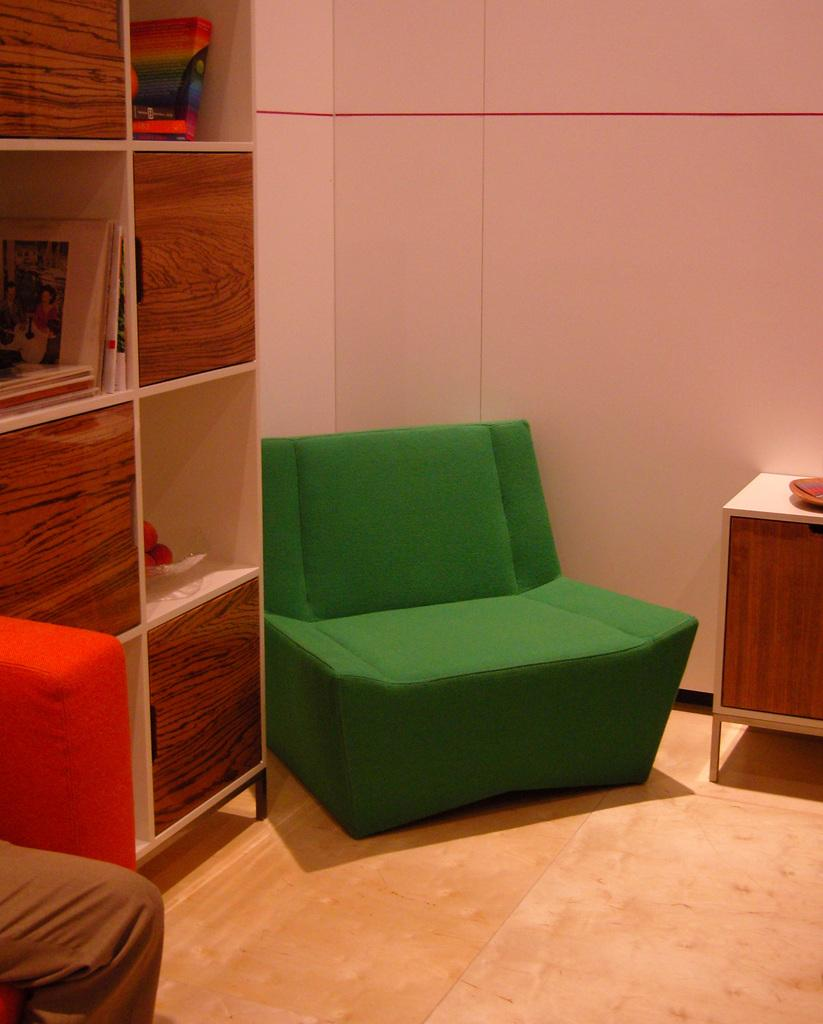What type of furniture is present in the image? There is a sofa, cupboards, and a table in the image. What is the primary subject of the image? There is a human in the image. Can you describe the setting where the human is located? The human is located in a room with a sofa, cupboards, and a table. What type of box can be seen attracting the human in the image? There is no box present in the image, and therefore no attraction to it can be observed. 